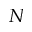Convert formula to latex. <formula><loc_0><loc_0><loc_500><loc_500>N</formula> 